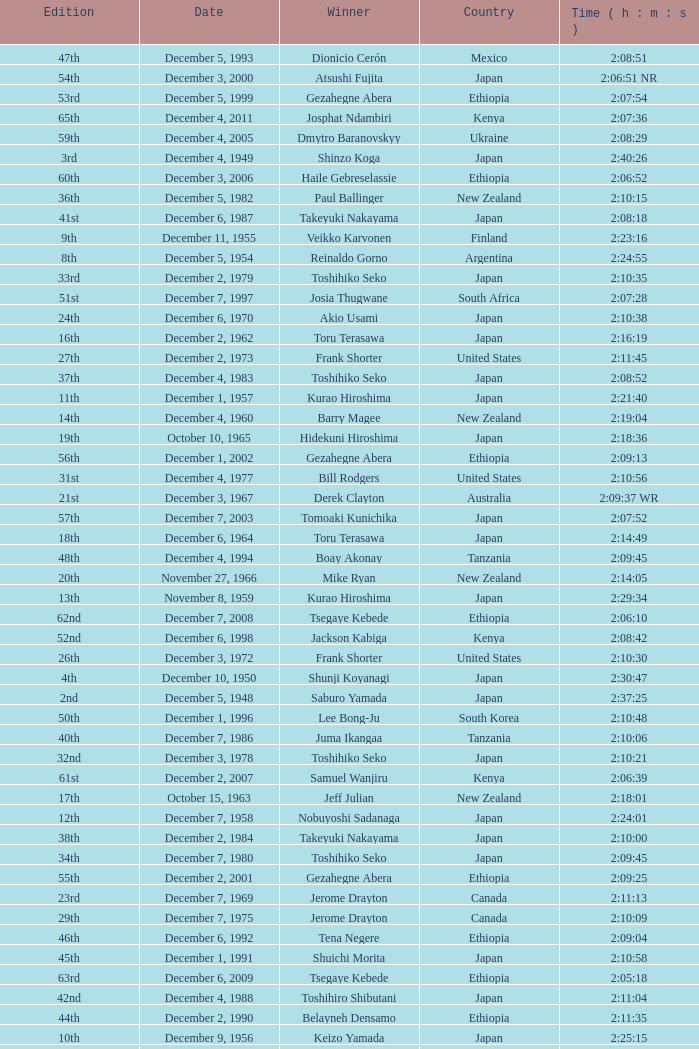What was the nationality of the winner of the 42nd Edition? Japan. 